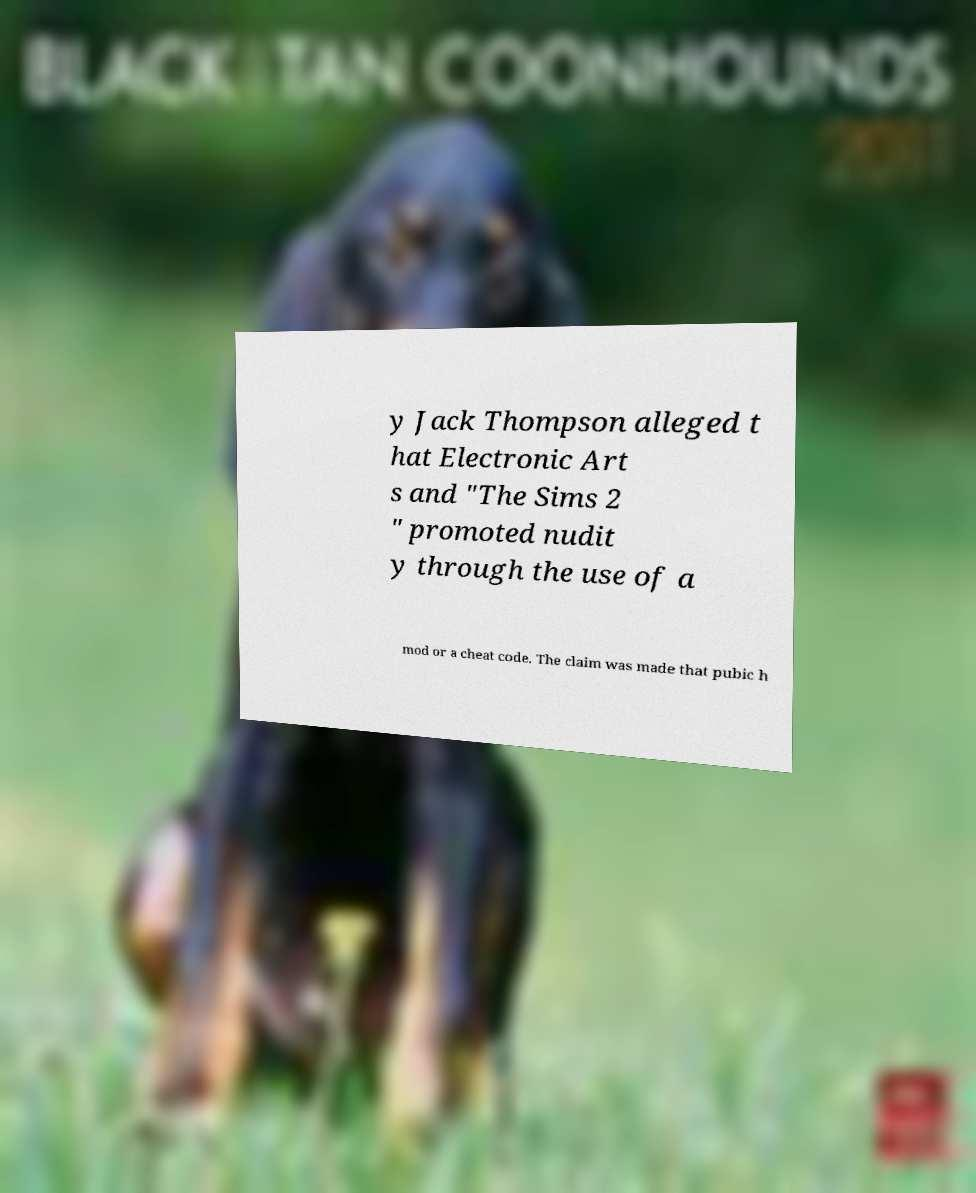Please identify and transcribe the text found in this image. y Jack Thompson alleged t hat Electronic Art s and "The Sims 2 " promoted nudit y through the use of a mod or a cheat code. The claim was made that pubic h 